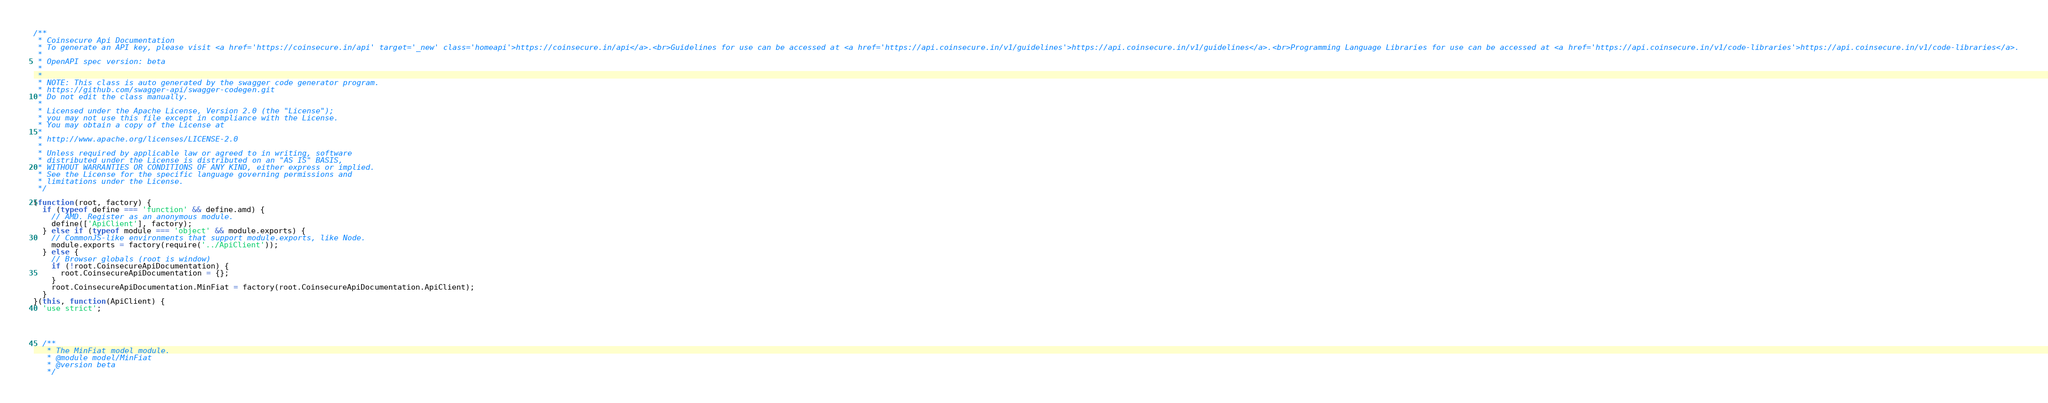<code> <loc_0><loc_0><loc_500><loc_500><_JavaScript_>/**
 * Coinsecure Api Documentation
 * To generate an API key, please visit <a href='https://coinsecure.in/api' target='_new' class='homeapi'>https://coinsecure.in/api</a>.<br>Guidelines for use can be accessed at <a href='https://api.coinsecure.in/v1/guidelines'>https://api.coinsecure.in/v1/guidelines</a>.<br>Programming Language Libraries for use can be accessed at <a href='https://api.coinsecure.in/v1/code-libraries'>https://api.coinsecure.in/v1/code-libraries</a>.
 *
 * OpenAPI spec version: beta
 * 
 *
 * NOTE: This class is auto generated by the swagger code generator program.
 * https://github.com/swagger-api/swagger-codegen.git
 * Do not edit the class manually.
 *
 * Licensed under the Apache License, Version 2.0 (the "License");
 * you may not use this file except in compliance with the License.
 * You may obtain a copy of the License at
 *
 * http://www.apache.org/licenses/LICENSE-2.0
 *
 * Unless required by applicable law or agreed to in writing, software
 * distributed under the License is distributed on an "AS IS" BASIS,
 * WITHOUT WARRANTIES OR CONDITIONS OF ANY KIND, either express or implied.
 * See the License for the specific language governing permissions and
 * limitations under the License.
 */

(function(root, factory) {
  if (typeof define === 'function' && define.amd) {
    // AMD. Register as an anonymous module.
    define(['ApiClient'], factory);
  } else if (typeof module === 'object' && module.exports) {
    // CommonJS-like environments that support module.exports, like Node.
    module.exports = factory(require('../ApiClient'));
  } else {
    // Browser globals (root is window)
    if (!root.CoinsecureApiDocumentation) {
      root.CoinsecureApiDocumentation = {};
    }
    root.CoinsecureApiDocumentation.MinFiat = factory(root.CoinsecureApiDocumentation.ApiClient);
  }
}(this, function(ApiClient) {
  'use strict';




  /**
   * The MinFiat model module.
   * @module model/MinFiat
   * @version beta
   */
</code> 